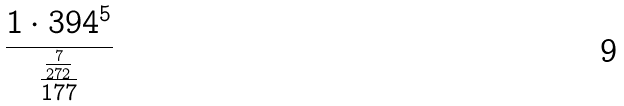Convert formula to latex. <formula><loc_0><loc_0><loc_500><loc_500>\frac { 1 \cdot 3 9 4 ^ { 5 } } { \frac { \frac { 7 } { 2 7 2 } } { 1 7 7 } }</formula> 